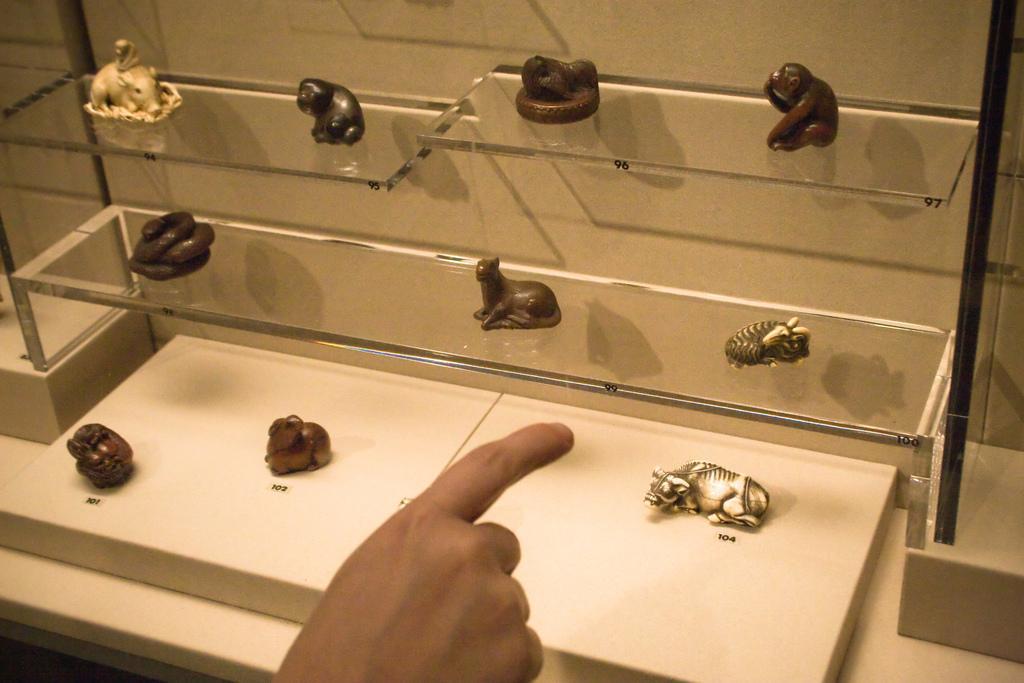Describe this image in one or two sentences. In this image we can see a few objects on the glass shelves, here is the human hand, here is the wall. 